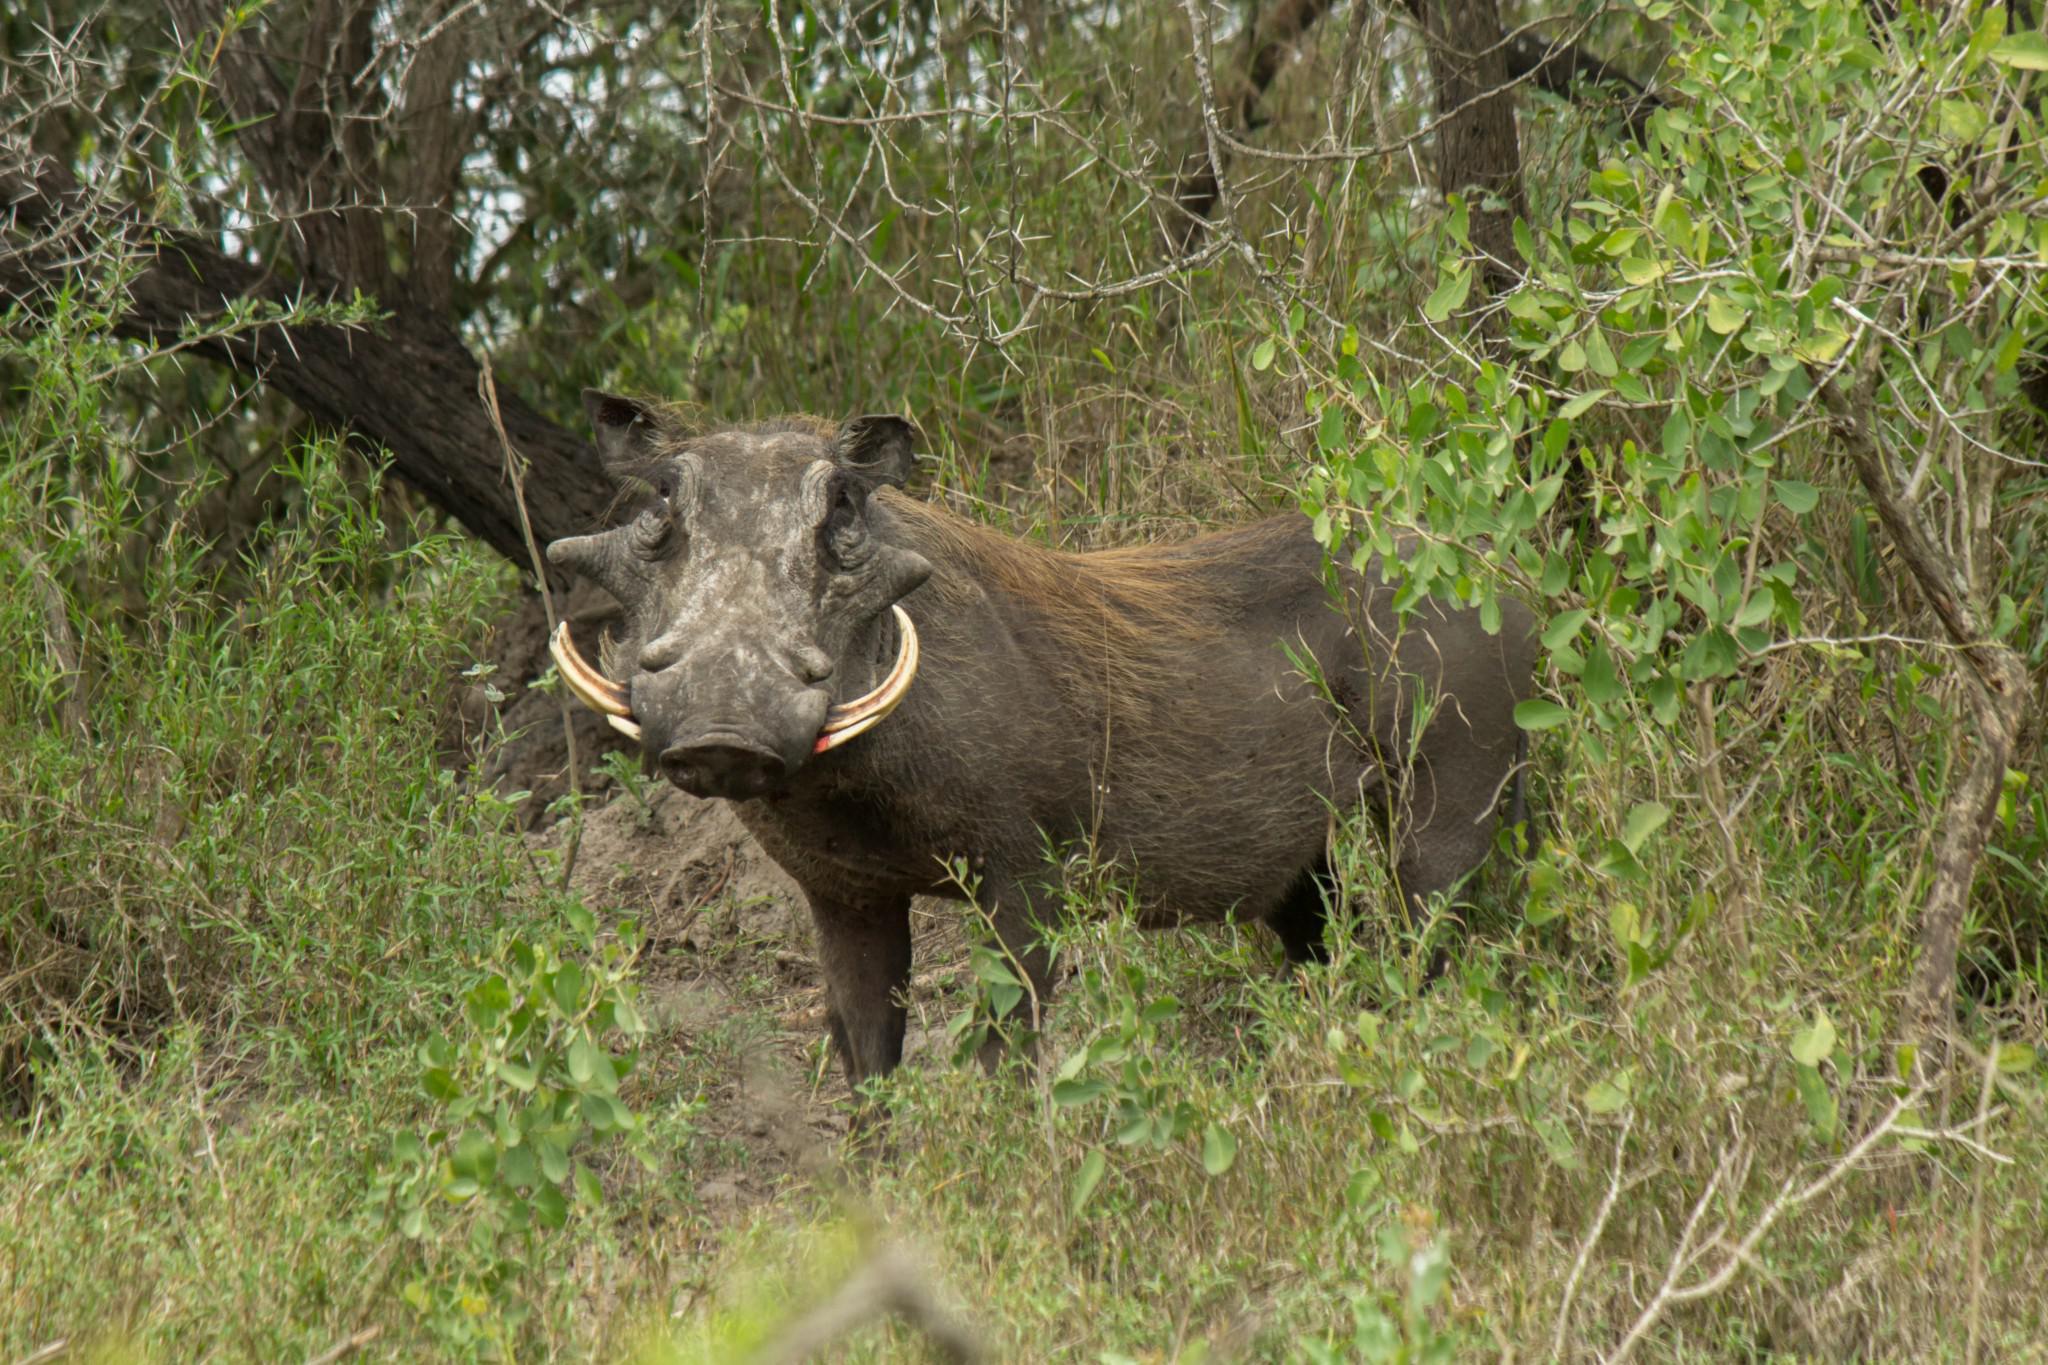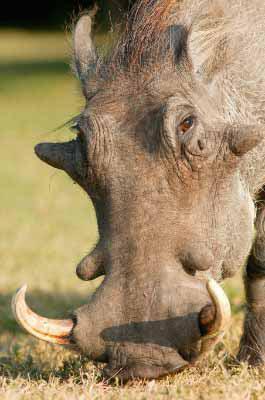The first image is the image on the left, the second image is the image on the right. Evaluate the accuracy of this statement regarding the images: "One image includes at least one bird with a standing warthog.". Is it true? Answer yes or no. No. The first image is the image on the left, the second image is the image on the right. Given the left and right images, does the statement "A boar is near the pig in one of the images." hold true? Answer yes or no. No. 